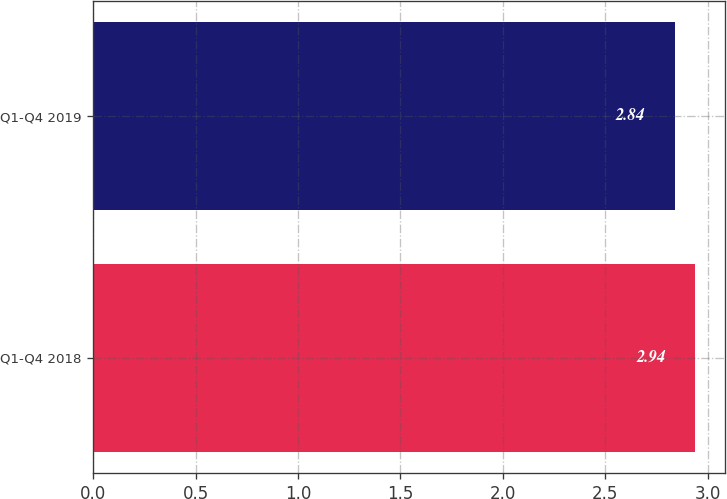<chart> <loc_0><loc_0><loc_500><loc_500><bar_chart><fcel>Q1-Q4 2018<fcel>Q1-Q4 2019<nl><fcel>2.94<fcel>2.84<nl></chart> 